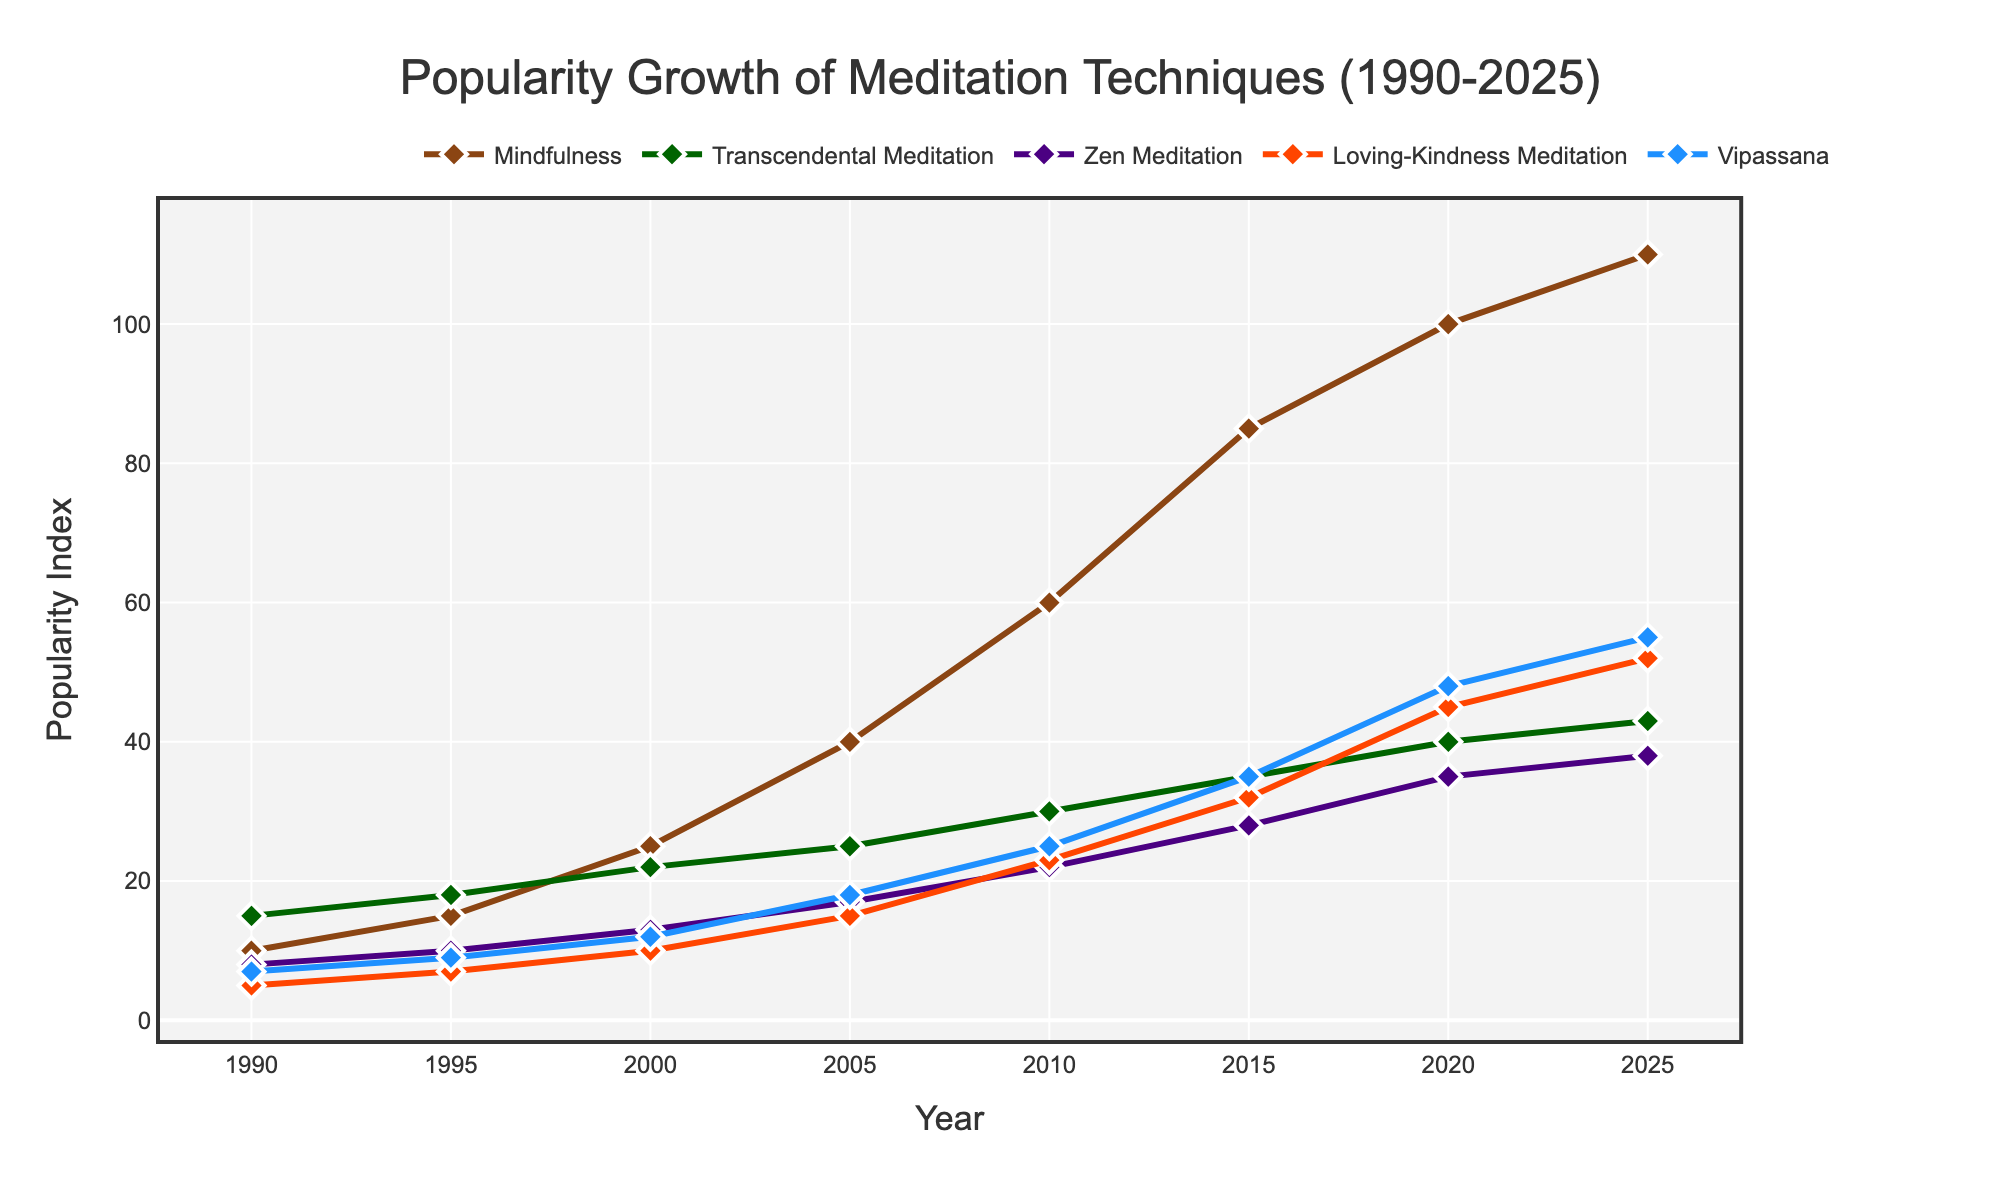Which meditation technique shows the highest growth in popularity from 1990 to 2025? To determine the technique with the highest growth, we need to compare the popularity index of each technique between 1990 and 2025. By checking the values, Mindfulness grows from 10 to 110, showing the highest increase of 100 points.
Answer: Mindfulness Which year shows the highest overall popularity index for all meditation techniques combined? To find the year with the highest combined popularity index, we sum the values for each technique per year and compare. For 2025: 110 + 43 + 38 + 52 + 55 = 298, which is higher than the sums of other years.
Answer: 2025 Between 1990 and 2010, which meditation technique gained the least in popularity? To identify the least gain in popularity, we calculate the difference for each technique between 1990 and 2010: Mindfulness (50), Transcendental Meditation (15), Zen Meditation (14), Loving-Kindness Meditation (18), Vipassana (18). The smallest increase is by Transcendental Meditation (15).
Answer: Transcendental Meditation Compare the popularity growth of Vipassana and Loving-Kindness Meditation between 2000 and 2020. Which one grew more, and by how much? The growth for Vipassana from 2000 to 2020 is 48 - 12 = 36. For Loving-Kindness Meditation, it's 45 - 10 = 35. So, Vipassana grew more by 36 - 35 = 1.
Answer: Vipassana, by 1 In 2015, which meditation technique had the closest popularity index to the average popularity index of all techniques that year? First, compute the average popularity index in 2015: (85 + 35 + 28 + 32 + 35) / 5 = 43. The closest value to 43 is 35, which corresponds to Transcendental Meditation and Vipassana.
Answer: Transcendental Meditation and Vipassana How does the popularity of Zen Meditation in 2000 compare to Mindfulness in 1990? Zen Meditation in 2000 has an index of 13, while Mindfulness in 1990 has an index of 10. By comparison, Zen Meditation in 2000 is 3 points higher.
Answer: Zen Meditation in 2000 is 3 points higher What is the average popularity index of Transcendental Meditation from 1990 to 2025? To find the average, sum the popularity indices of Transcendental Meditation for each year and divide by the number of years: (15 + 18 + 22 + 25 + 30 + 35 + 40 + 43) / 8 = 228 / 8 = 28.5.
Answer: 28.5 In which year did Loving-Kindness Meditation first surpass a popularity index of 30? By examining the data, Loving-Kindness Meditation first surpasses an index of 30 in 2015 with a value of 32.
Answer: 2015 